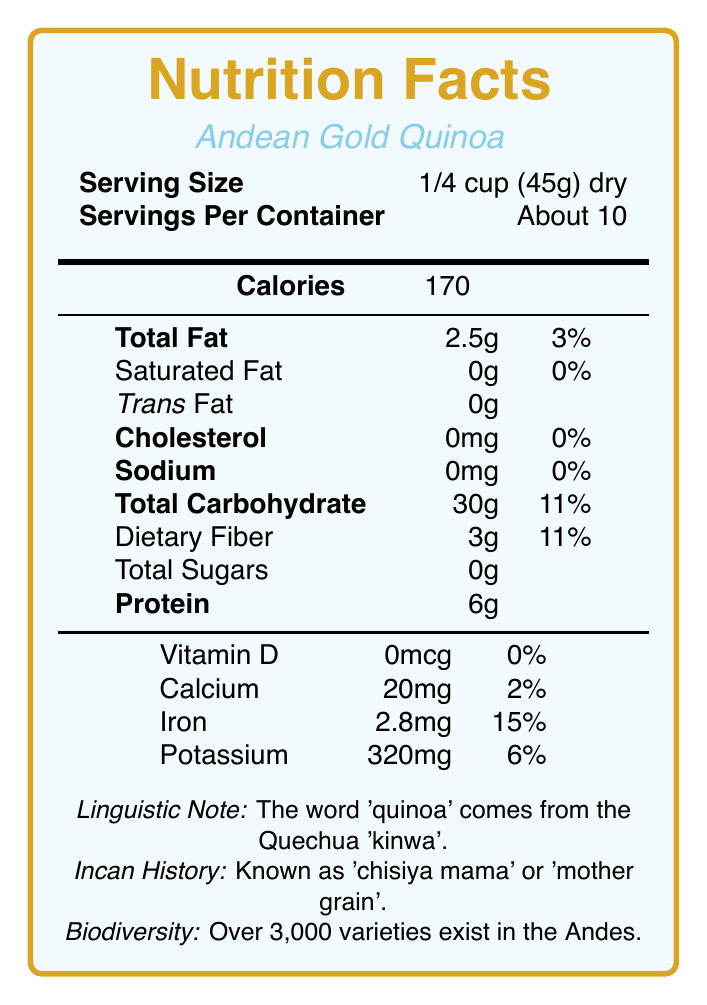what is the serving size for Andean Gold Quinoa? The serving size is explicitly stated under the "Serving Size" section.
Answer: 1/4 cup (45g) dry how many servings are approximately in each container of Andean Gold Quinoa? The document specifies "Servings Per Container" as "About 10."
Answer: About 10 what is the Quechua name for quinoa? The "Linguistic Note" in the document mentions that 'quinoa' comes from the Quechua language, where it is called 'kinwa'.
Answer: kinwa how many calories are in one serving of Andean Gold Quinoa? The "Calories" section explicitly states there are 170 calories per serving.
Answer: 170 what percentage of daily iron intake does one serving of Andean Gold Quinoa provide? The document lists iron content as 2.8mg, which is 15% of the daily value.
Answer: 15% how much protein does one serving contain? The "Protein" section indicates that one serving contains 6g of protein.
Answer: 6g what is the historical significance of quinoa to the Incan civilization? A. It was used for making alcoholic beverages B. It was a staple food and religiously significant C. It was used primarily for animal feed D. It was not known to the Incas The "Incan History" section states that quinoa was a staple food and considered sacred by the Incas.
Answer: B what does the phrase 'chisiya mama' mean in the context of quinoa? A. Sacred seed B. Golden grain C. Mother grain D. Hidden treasure The "Incan History" section mentions that the Incas referred to quinoa as 'chisiya mama', which means 'mother grain'.
Answer: C is there any trans fat in one serving of Andean Gold Quinoa? The document explicitly lists Trans Fat as 0g.
Answer: No describe the main idea of the document The document combines nutritional information with historical and linguistic notes related to quinoa, highlighting both its dietary values and cultural importance.
Answer: The document provides the nutrition facts and historical background of Andean Gold Quinoa. It includes serving size, calories, fat, cholesterol, sodium, carbohydrates, protein, vitamins, and minerals. Additionally, it explains the Quechua origin of the name 'quinoa', its significance to the Incan civilization, and the biodiversity of quinoa varieties. how many varieties of quinoa are there in the Andean region? The "Biodiversity" section notes that there are over 3,000 varieties of quinoa.
Answer: Over 3,000 what is the amount of calcium provided by one serving of Andean Gold Quinoa? A. 2mg B. 10mg C. 20mg D. 30mg The document states that calcium content is 20mg per serving.
Answer: C what is the daily value percentage of dietary fiber in one serving? The "Dietary Fiber" section lists the daily value percentage as 11%.
Answer: 11% how much cholesterol is in one serving? The document specifies cholesterol content as 0mg.
Answer: 0mg who coined the term 'quinua'? While the linguistic note states that the Spanish conquistadors hispanicized the Quechua word 'kinwa' to 'quinua', it does not provide the name of the individual who coined the term.
Answer: Not enough information how did the Spanish conquest affect quinoa cultivation? The document mentions in the "Modern Revival" section that quinoa's cultivation declined post-Spanish conquest but later revived globally as a superfood.
Answer: Quinoa experienced a decline after the Spanish conquest but has seen a global resurgence in modern times due to its nutritional recognition. how many grams of dietary fiber does one serving of Andean Gold Quinoa contain? The "Dietary Fiber" section lists 3g per serving.
Answer: 3g 